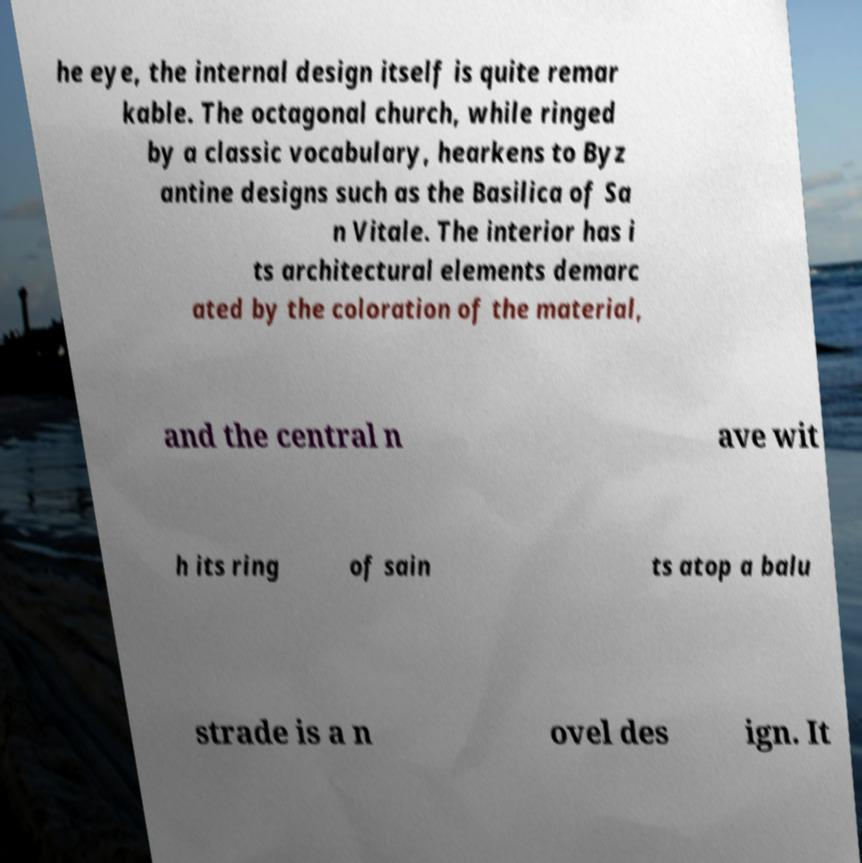Can you read and provide the text displayed in the image?This photo seems to have some interesting text. Can you extract and type it out for me? he eye, the internal design itself is quite remar kable. The octagonal church, while ringed by a classic vocabulary, hearkens to Byz antine designs such as the Basilica of Sa n Vitale. The interior has i ts architectural elements demarc ated by the coloration of the material, and the central n ave wit h its ring of sain ts atop a balu strade is a n ovel des ign. It 